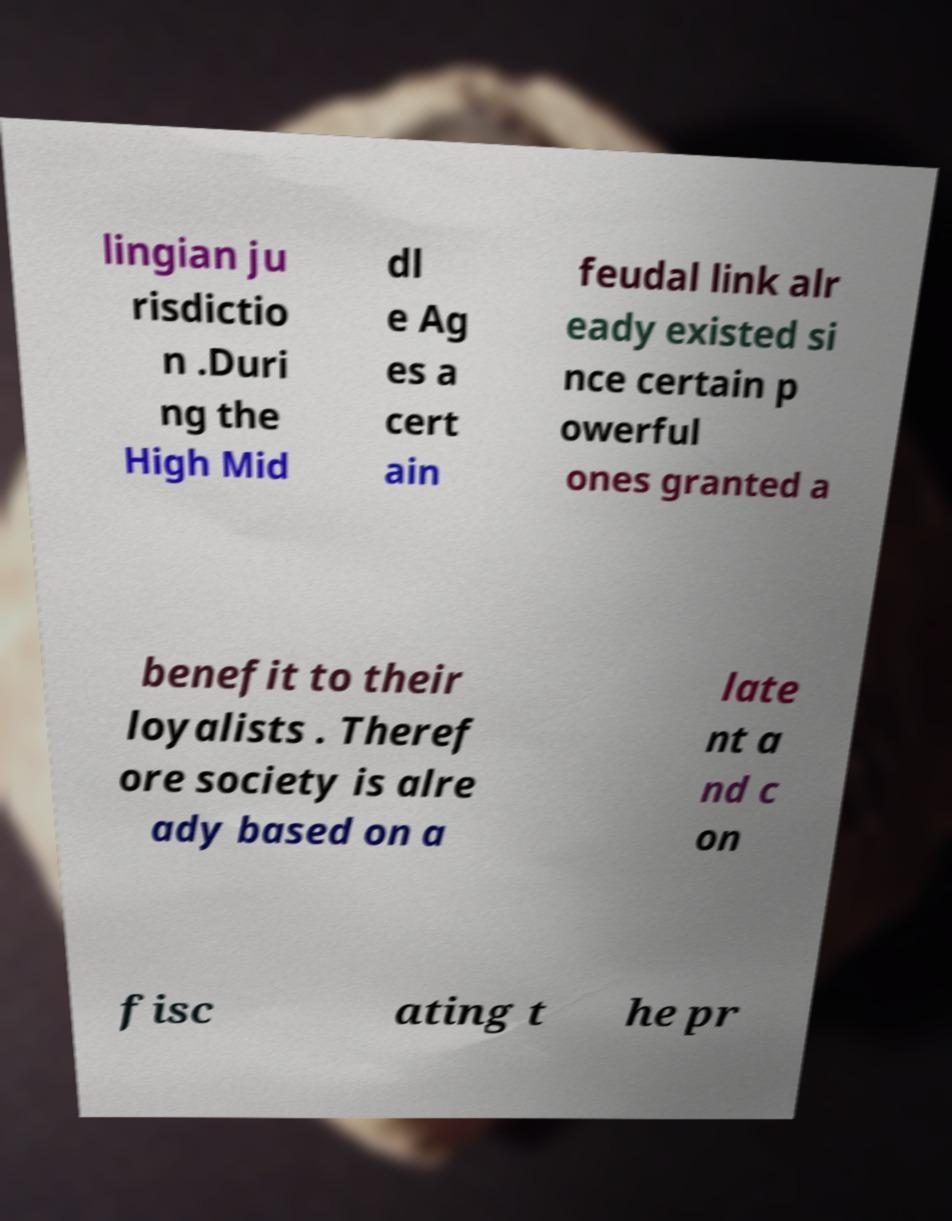Can you read and provide the text displayed in the image?This photo seems to have some interesting text. Can you extract and type it out for me? lingian ju risdictio n .Duri ng the High Mid dl e Ag es a cert ain feudal link alr eady existed si nce certain p owerful ones granted a benefit to their loyalists . Theref ore society is alre ady based on a late nt a nd c on fisc ating t he pr 